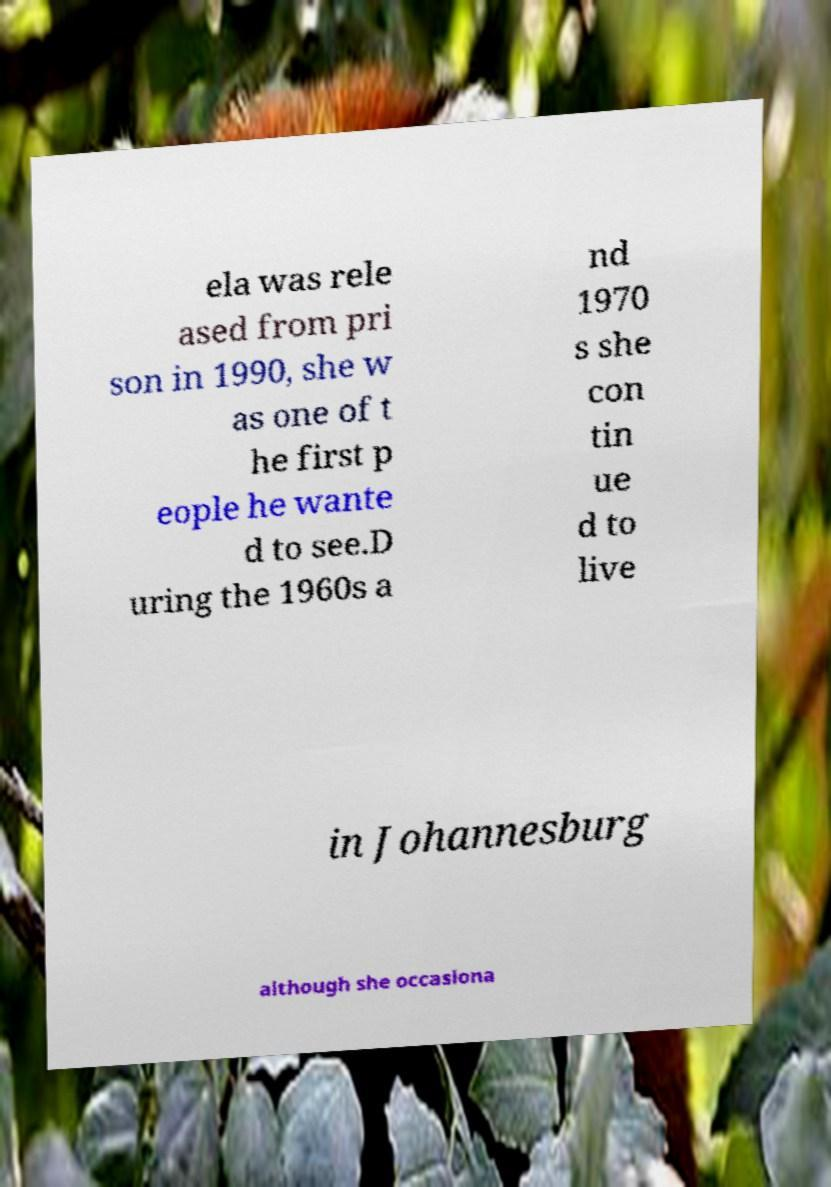Can you accurately transcribe the text from the provided image for me? ela was rele ased from pri son in 1990, she w as one of t he first p eople he wante d to see.D uring the 1960s a nd 1970 s she con tin ue d to live in Johannesburg although she occasiona 